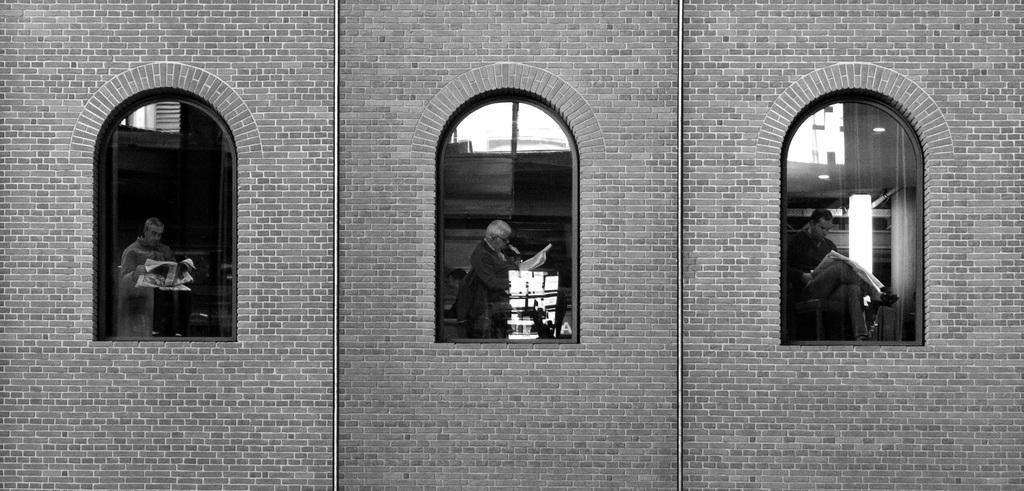Can you describe this image briefly? In this image I can see a brick wall which has windows. I can also see people are holding some objects in hands. This picture is black and white in color. 